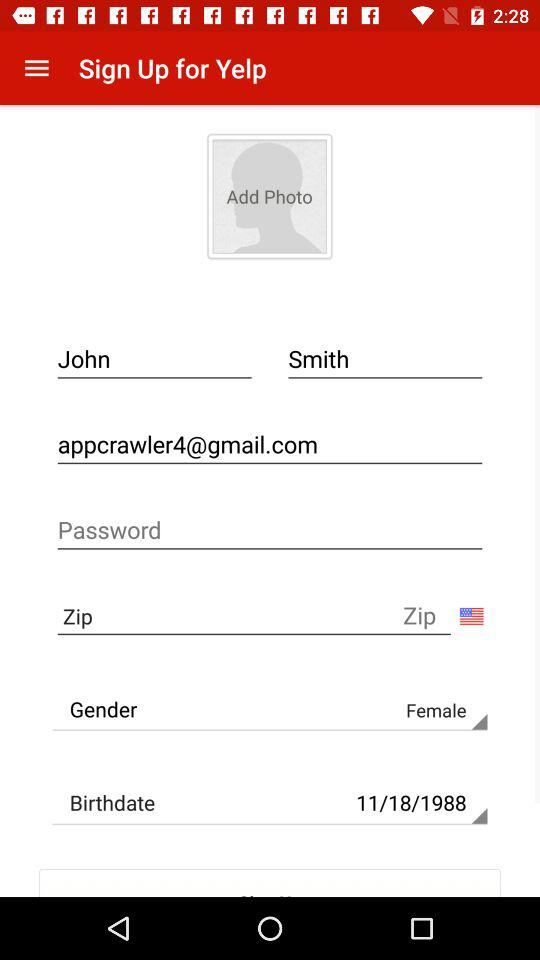How many more text inputs are there for the first and last name field than the email address field?
Answer the question using a single word or phrase. 1 